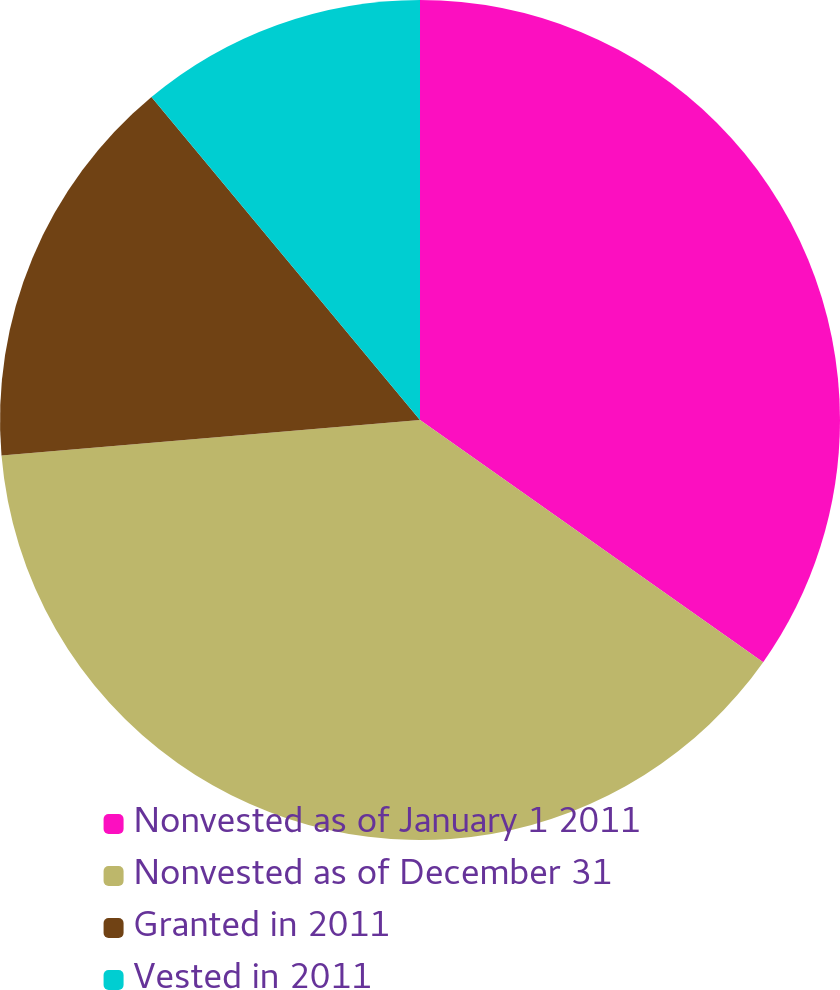<chart> <loc_0><loc_0><loc_500><loc_500><pie_chart><fcel>Nonvested as of January 1 2011<fcel>Nonvested as of December 31<fcel>Granted in 2011<fcel>Vested in 2011<nl><fcel>34.78%<fcel>38.87%<fcel>15.31%<fcel>11.04%<nl></chart> 